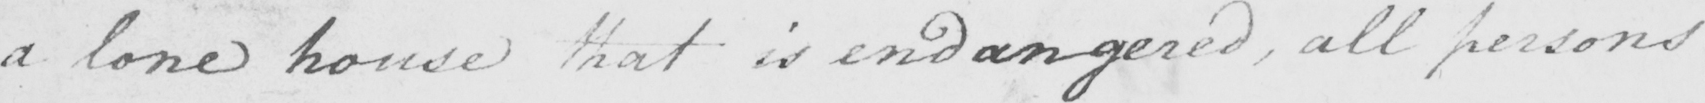Can you read and transcribe this handwriting? a lone house that is endangered , all persons 